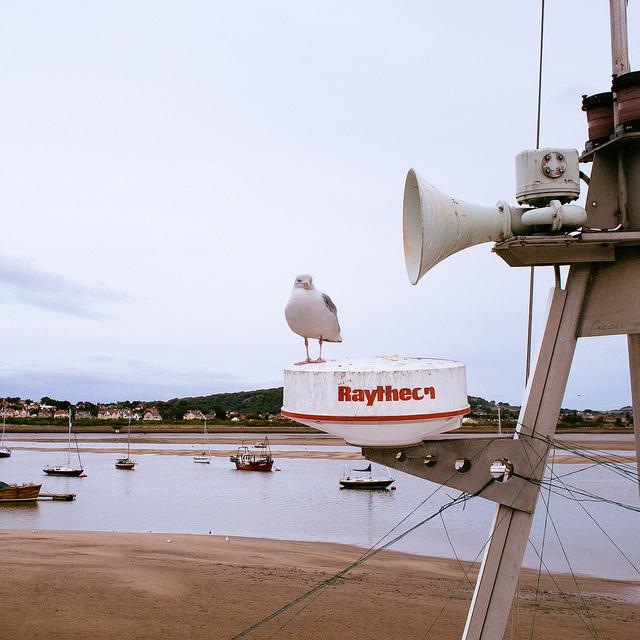What type of bird is on the Raytheon?
Concise answer only. Seagull. What will happen if the loudspeaker goes off?
Short answer required. Bird will fly away. How many boats are in the picture?
Answer briefly. 7. 